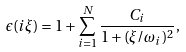<formula> <loc_0><loc_0><loc_500><loc_500>\epsilon ( i \xi ) = 1 + \sum _ { i = 1 } ^ { N } \frac { C _ { i } } { 1 + ( \xi / \omega _ { i } ) ^ { 2 } } ,</formula> 